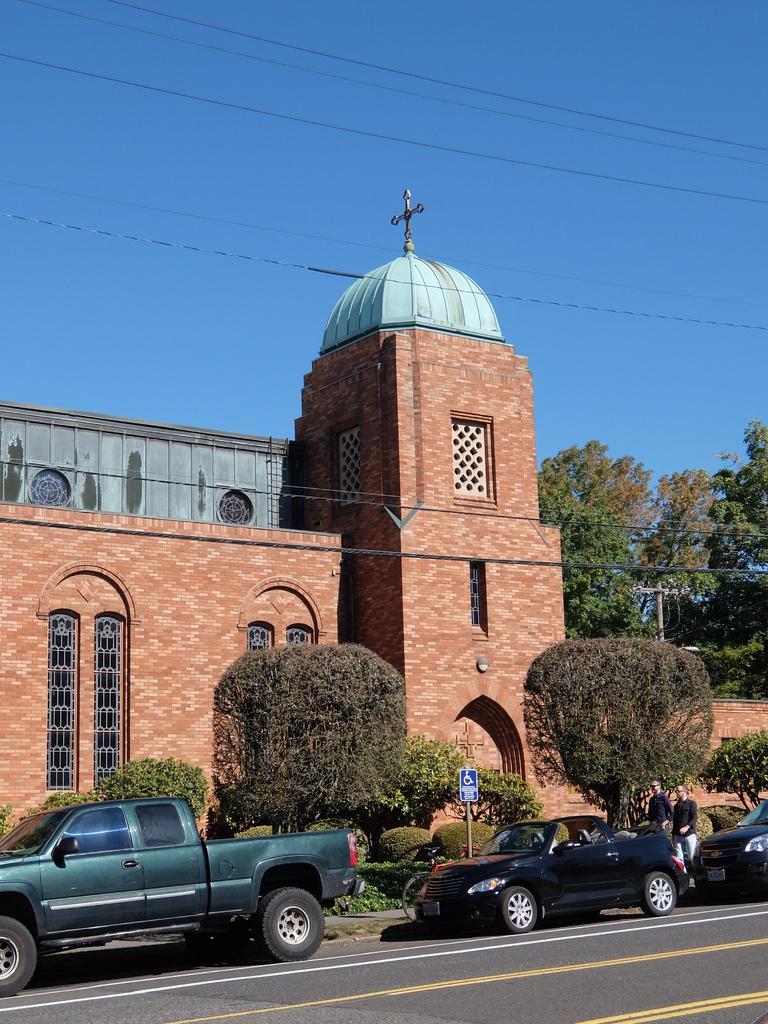Can you describe this image briefly? This image is taken outdoors. At the top of the image there is a sky and there are a few wires. At the bottom of the image there is a road. In the middle of the image there is a church with walls, windows, a roof and doors and there is a cross symbol. There are a few trees and plants. There is a pole. There is a signboard and a few cars are parked on the road. Two people are walking on the road. 